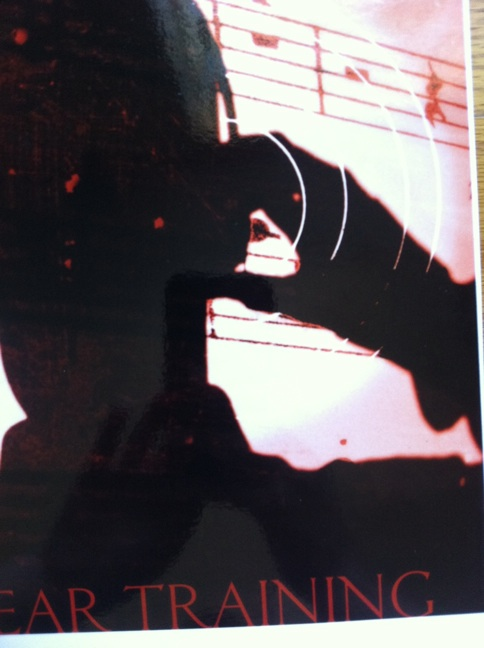Imagine a real-world scenario for this image. In a cozy, candle-lit room, a young musician practices with intense focus. The dim lighting accentuates the contours of their passionate movements, as they prepare for an upcoming conservatory exam. With every note, they are closer to achieving their dream of becoming a professional musician.  Can you describe another real-world scenario for this image? In an intimate classroom setting, a teacher demonstrates ear training techniques to a small group of aspiring musicians. The shadowy figure in the background is the teacher, whose passion for music is evident in every gesture and instruction given to the attentive students, highlighting the transformative power of dedicated practice. 